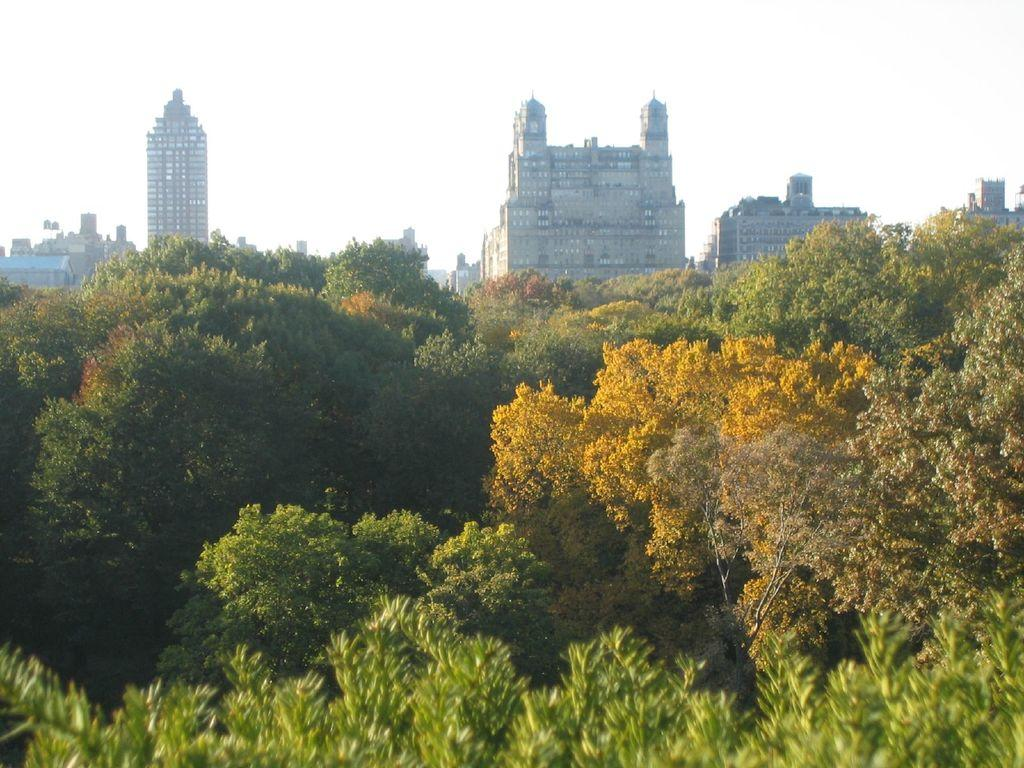What type of natural environment is at the bottom of the image? There is a forest at the bottom of the image. What type of structures can be seen in the background of the image? There are tall buildings in the background of the image. How are the buildings arranged in relation to each other? The buildings are positioned one beside the other. What is visible at the top of the image? The sky is visible at the top of the image. What type of disgusting journey can be seen taking place in the image? There is no journey or any indication of disgust present in the image. What type of border separates the forest from the buildings in the image? There is no border visible in the image; it simply shows a forest at the bottom and tall buildings in the background. 